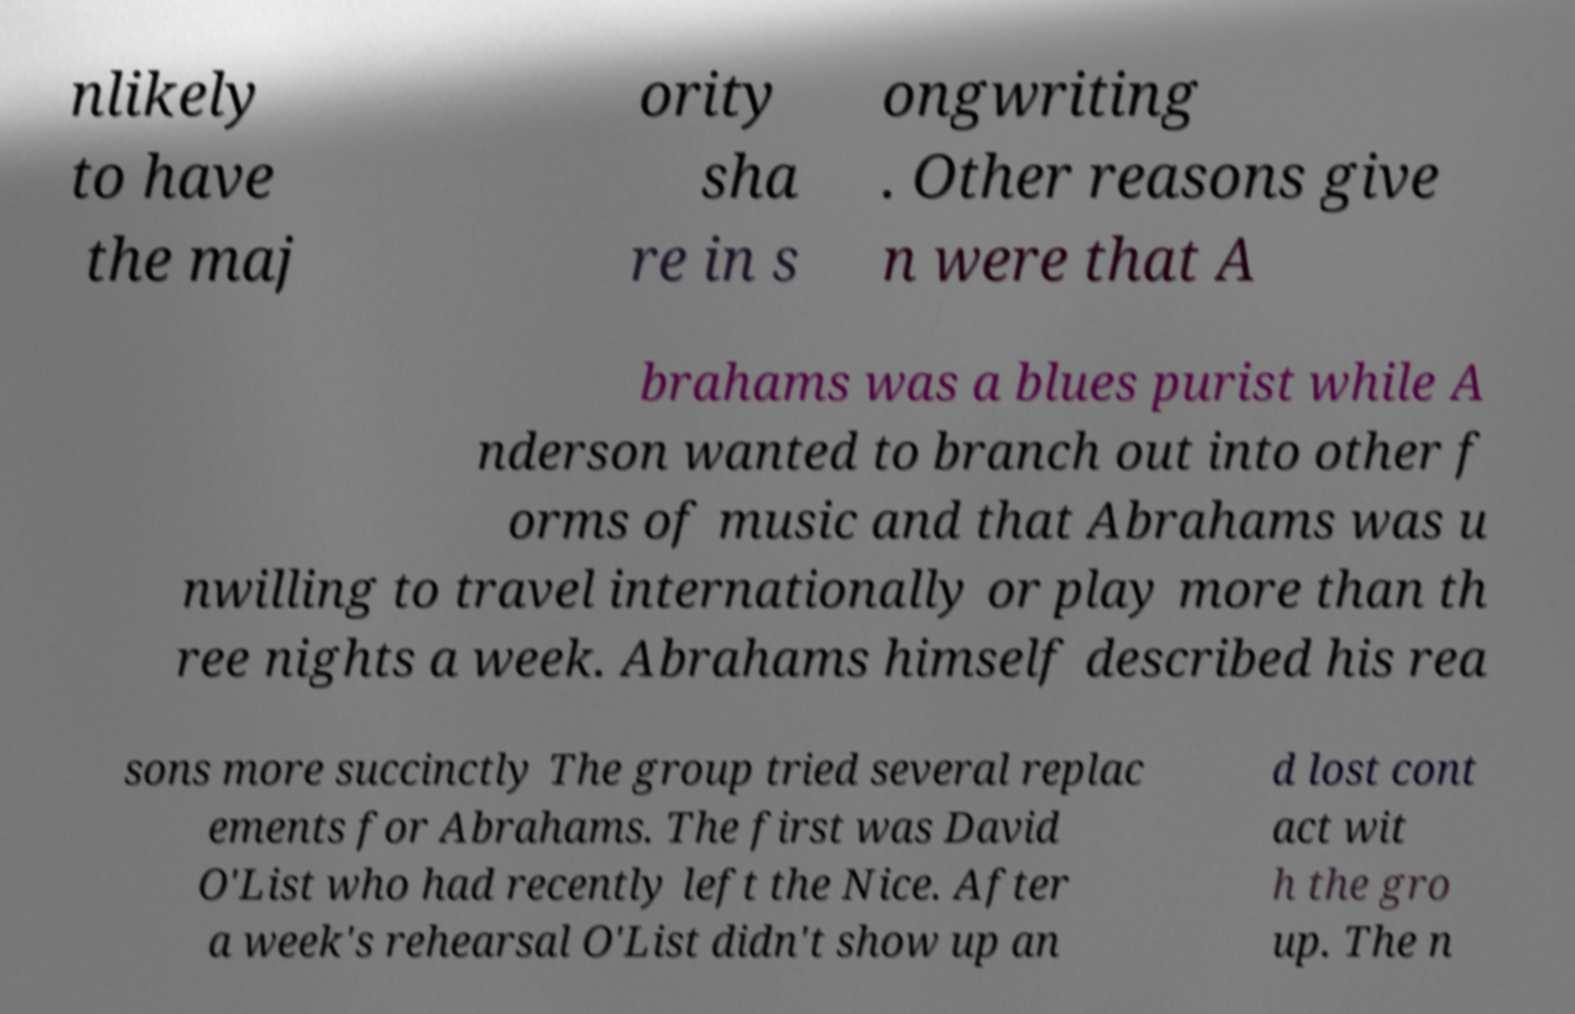Can you accurately transcribe the text from the provided image for me? nlikely to have the maj ority sha re in s ongwriting . Other reasons give n were that A brahams was a blues purist while A nderson wanted to branch out into other f orms of music and that Abrahams was u nwilling to travel internationally or play more than th ree nights a week. Abrahams himself described his rea sons more succinctly The group tried several replac ements for Abrahams. The first was David O'List who had recently left the Nice. After a week's rehearsal O'List didn't show up an d lost cont act wit h the gro up. The n 